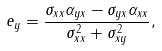<formula> <loc_0><loc_0><loc_500><loc_500>e _ { y } = { \frac { { \sigma _ { x x } \alpha _ { y x } - \sigma _ { y x } \alpha _ { x x } } } { { \sigma _ { x x } ^ { 2 } + \sigma _ { x y } ^ { 2 } } } } ,</formula> 